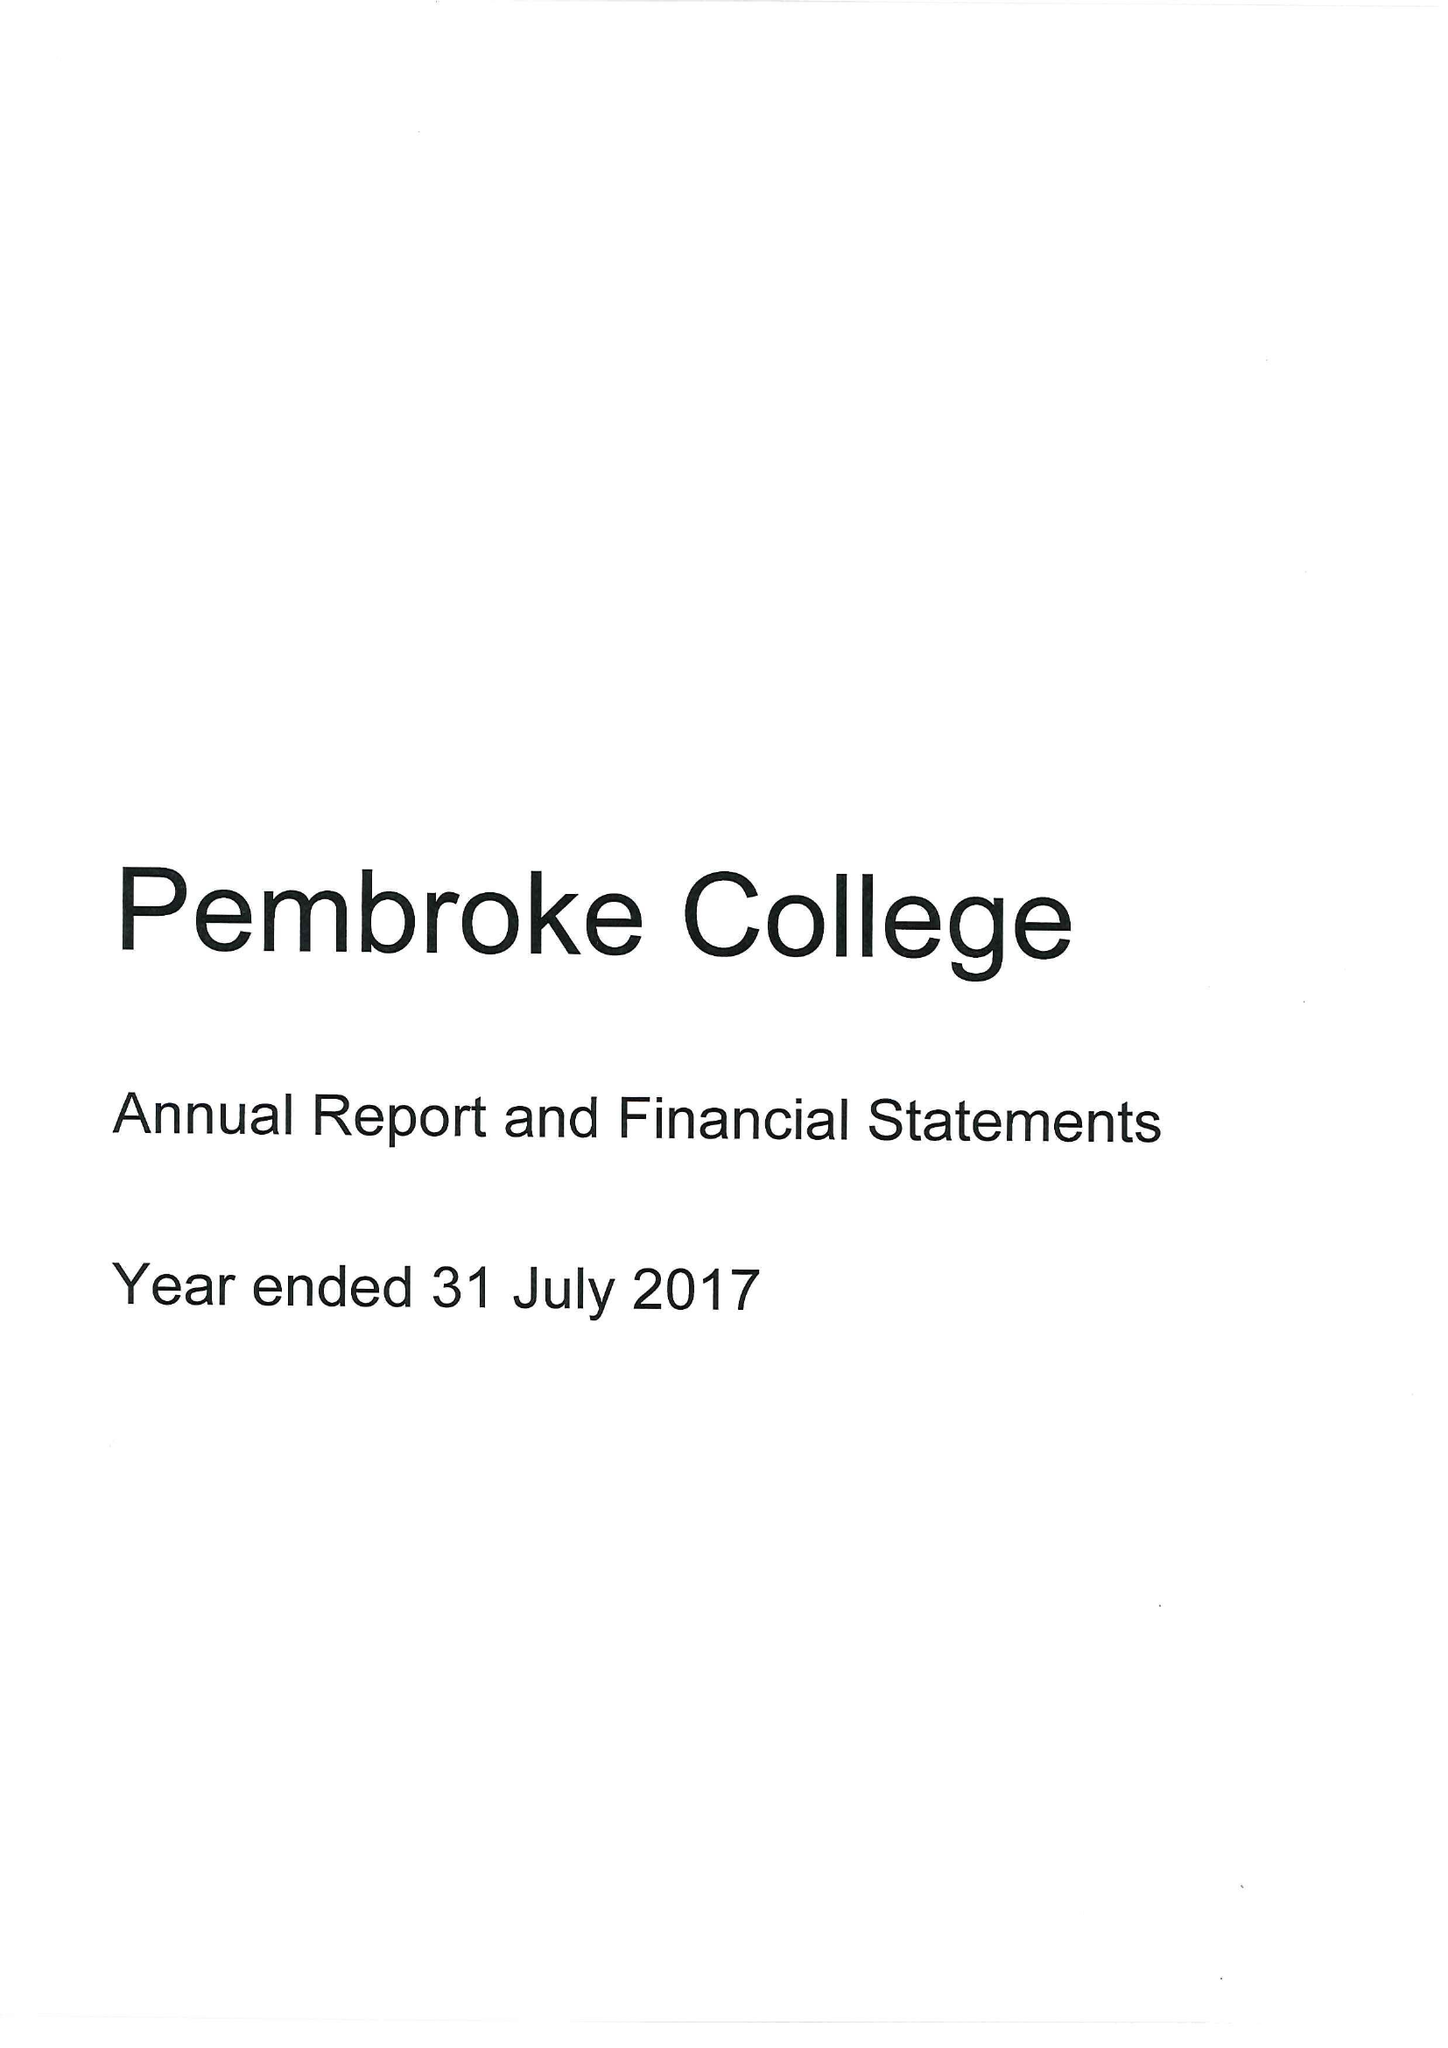What is the value for the report_date?
Answer the question using a single word or phrase. 2017-07-31 